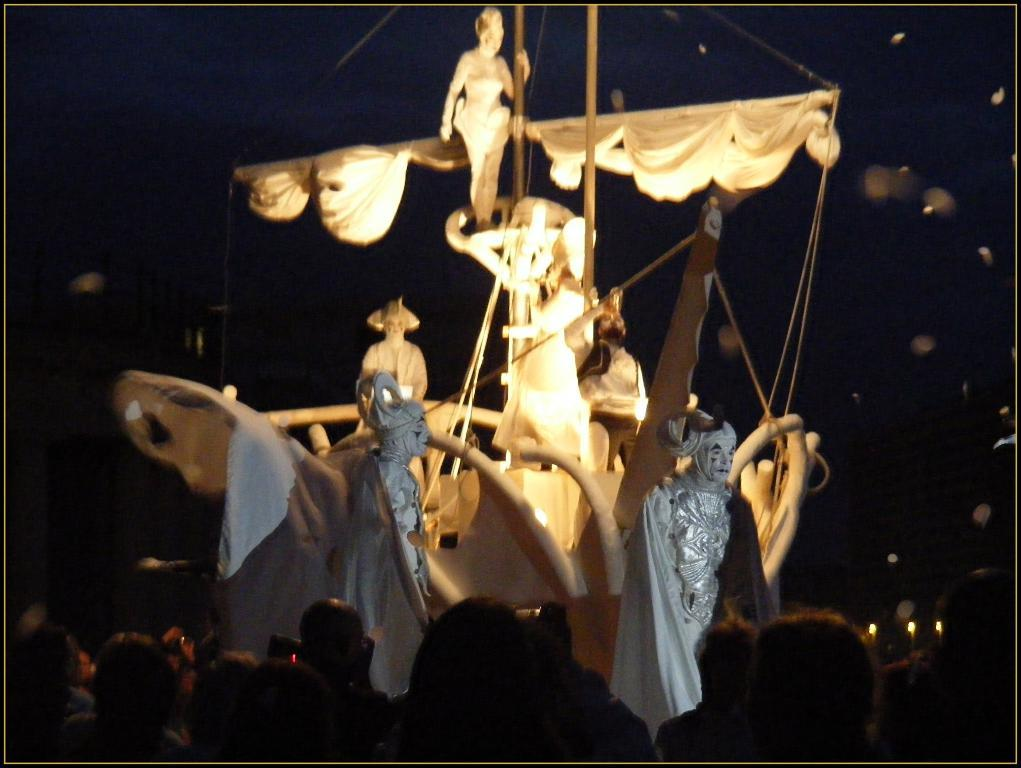What is the main subject of the image? The main subject of the image is a model of a ship. What features can be seen on the model? The model has sculptures, rods, poles, and lights. Are there any people visible in the image? Yes, there are people at the bottom of the image. What is the color of the background in the image? The background of the image is black. What type of wound can be seen on the model of the ship? There is no wound present on the model of the ship in the image. What type of machine is used to power the lights on the model? The image does not provide information about the power source for the lights on the model. 